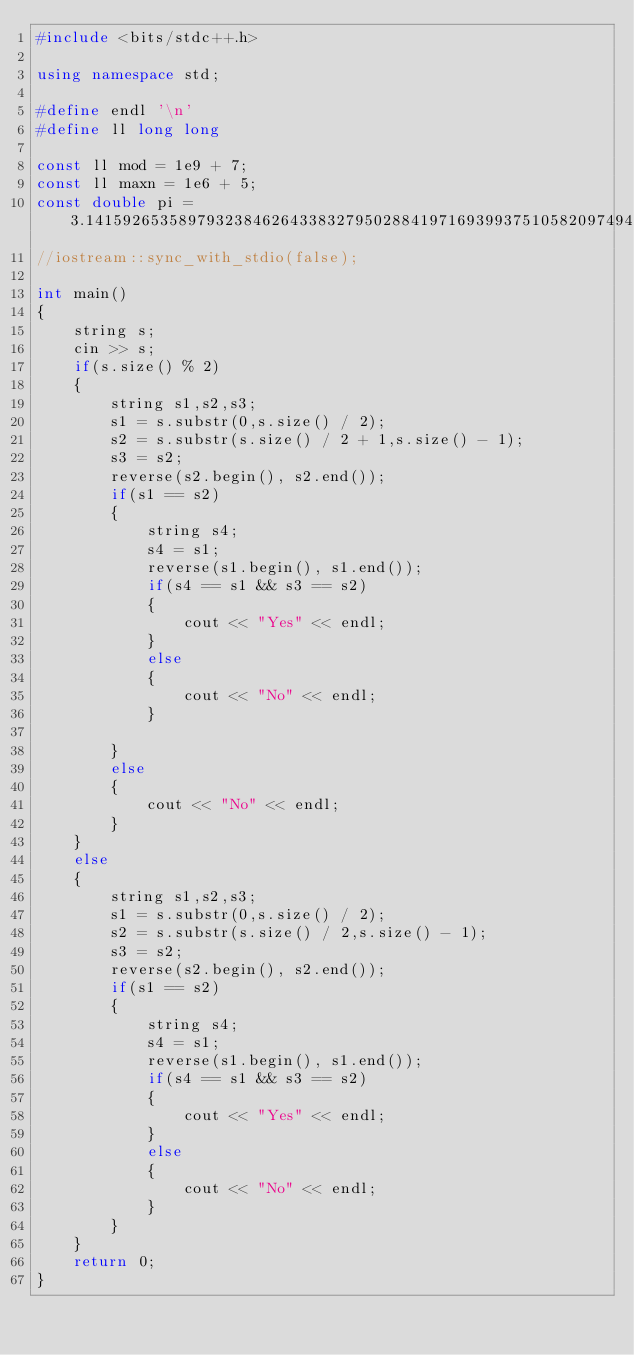<code> <loc_0><loc_0><loc_500><loc_500><_C++_>#include <bits/stdc++.h>

using namespace std;

#define endl '\n'
#define ll long long

const ll mod = 1e9 + 7;
const ll maxn = 1e6 + 5;
const double pi = 3.1415926535897932384626433832795028841971693993751058209749445923078;
//iostream::sync_with_stdio(false);

int main()
{
    string s;
    cin >> s;
    if(s.size() % 2)
    {
        string s1,s2,s3;
        s1 = s.substr(0,s.size() / 2);
        s2 = s.substr(s.size() / 2 + 1,s.size() - 1);
        s3 = s2;
        reverse(s2.begin(), s2.end());
        if(s1 == s2)
        {
            string s4;
            s4 = s1;
            reverse(s1.begin(), s1.end());
            if(s4 == s1 && s3 == s2)
            {
                cout << "Yes" << endl;
            }
            else
            {
                cout << "No" << endl;
            }

        }
        else
        {
            cout << "No" << endl;
        }
    }
    else
    {
        string s1,s2,s3;
        s1 = s.substr(0,s.size() / 2);
        s2 = s.substr(s.size() / 2,s.size() - 1);
        s3 = s2;
        reverse(s2.begin(), s2.end());
        if(s1 == s2)
        {
            string s4;
            s4 = s1;
            reverse(s1.begin(), s1.end());
            if(s4 == s1 && s3 == s2)
            {
                cout << "Yes" << endl;
            }
            else
            {
                cout << "No" << endl;
            }
        }
    }
    return 0;
}

</code> 